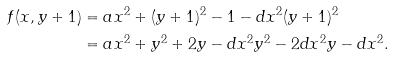<formula> <loc_0><loc_0><loc_500><loc_500>f ( x , y + 1 ) & = a x ^ { 2 } + ( y + 1 ) ^ { 2 } - 1 - d x ^ { 2 } ( y + 1 ) ^ { 2 } \\ & = a x ^ { 2 } + y ^ { 2 } + 2 y - d x ^ { 2 } y ^ { 2 } - 2 d x ^ { 2 } y - d x ^ { 2 } .</formula> 